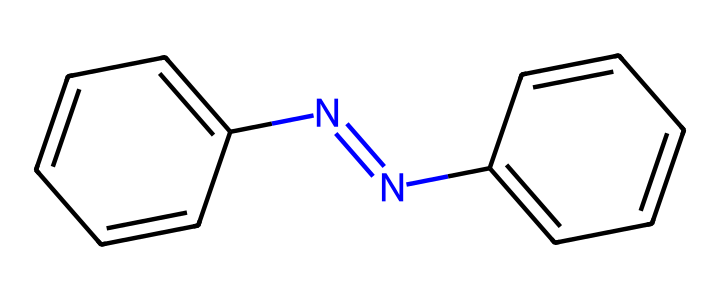What is the total number of nitrogen atoms in the structure? In the provided SMILES representation, "N=N" indicates the presence of a nitrogen double bond. There are two nitrogen atoms present in total in this azobenzene structure.
Answer: 2 How many carbon atoms are present in the molecule? By analyzing the chemical structure, there are a total of 12 carbon atoms present, derived from the two benzene rings and the linking azo (N=N) group.
Answer: 12 What type of spectroscopy can be used to analyze the photoreactivity of azobenzene? Given the properties of azobenzene, UV-Vis spectroscopy is commonly utilized to study its photoreactivity due to the absorption of UV light which induces isomerization.
Answer: UV-Vis What is the significance of the azo bond in this molecule? The azo bond (N=N) is crucial for the photoswitching capability of azobenzene, allowing it to undergo conformational changes upon exposure to light.
Answer: Photoswitching How many pi bonds are present in the structure? Each of the double bonds in azobenzene, including those in the rings and the azo bond, includes pi bonds. In total, there are 6 pi bonds: 4 from the aromatic carbons in the rings and 1 from the azo bond itself.
Answer: 6 What potential application does azobenzene have in drug delivery systems? Azobenzene's ability to switch between cis and trans configurations under light exposure can be exploited for targeted and controlled drug release in pharmaceutical applications.
Answer: Controlled release 